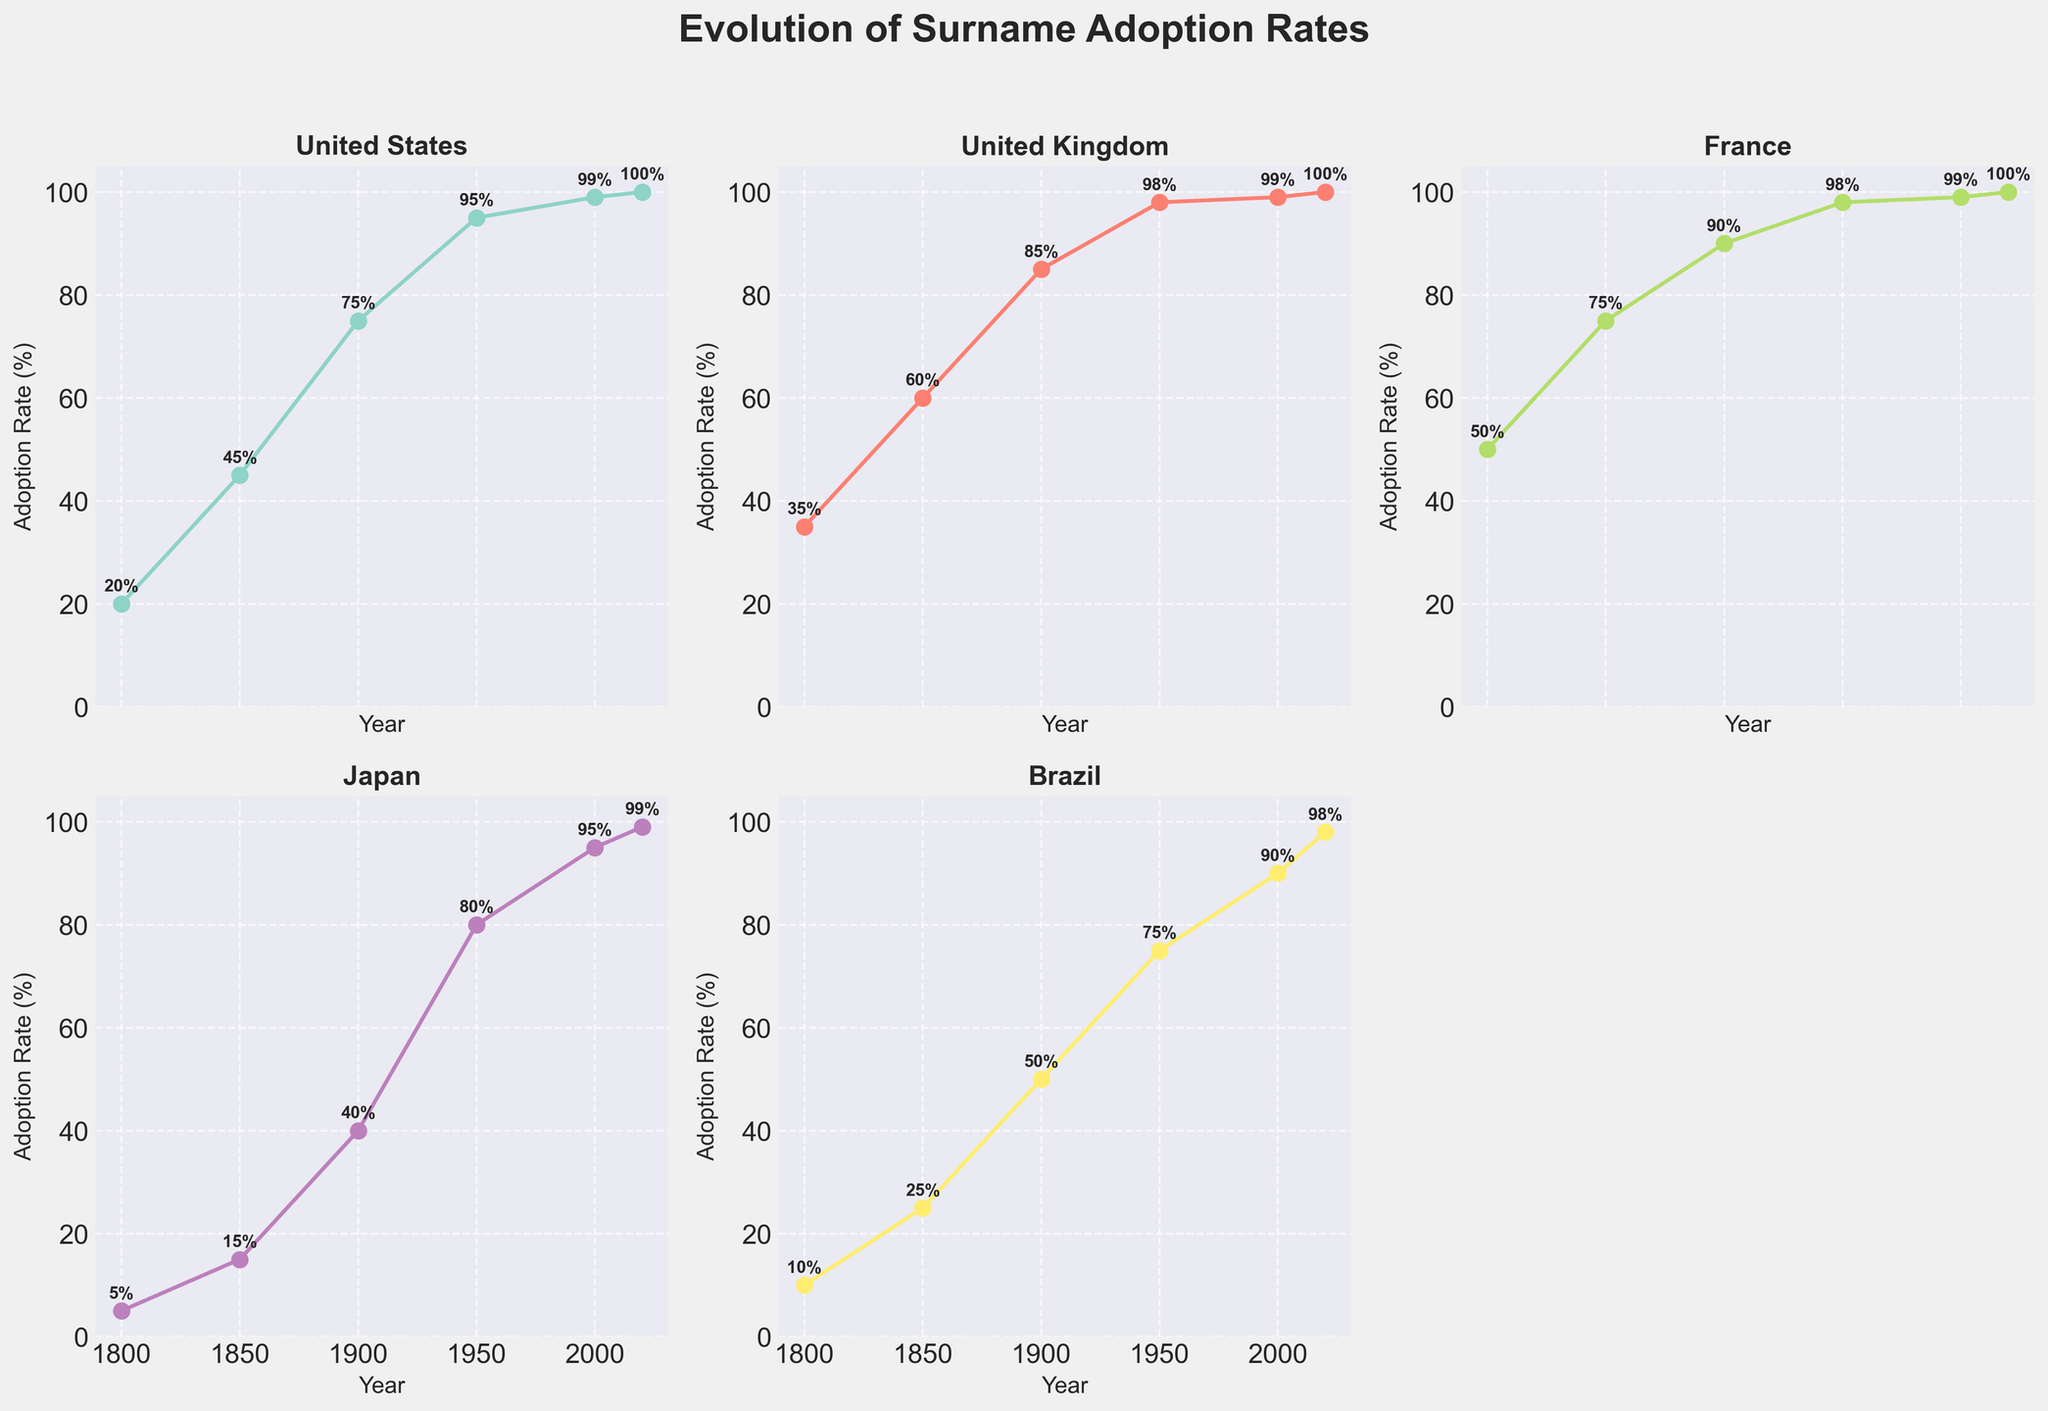What is the title of the figure? The title is displayed at the top of the figure and helps to understand the overall content of the plots. The title reads "Evolution of Surname Adoption Rates".
Answer: Evolution of Surname Adoption Rates Which country had the highest surname adoption rate in 1800? Looking at the y-values for each country's subplot in the year 1800, the country with the highest value shows the highest adoption rate for that year. France had the highest rate at 50%.
Answer: France What is the adoption rate of surnames in Japan in the year 2000? Identify the point corresponding to the year 2000 in Japan's subplot and note the y-value associated with it. For Japan, this value is 95%.
Answer: 95% How much did the adoption rate in the United States increase from 1800 to 1850? Subtract the adoption rate in 1800 from the rate in 1850 in the United States subplot. The values are 45% (1850) - 20% (1800) = 25%.
Answer: 25% Which country achieved a 100% adoption rate first, and in which year? By observing the subplots, identify the earliest year in which any country’s adoption rate reaches 100%. The United Kingdom reached 100% first in 2020.
Answer: United Kingdom, 2020 What is the average adoption rate increase per century for Brazil from 1800 to 2020? Calculate the total increase from 1800 to 2020, then divide by the number of centuries (2). The rate increased from 10% to 98%, so (98 - 10) / 2 = 44%.
Answer: 44% Compare the surname adoption rates of France and Brazil in 1950. Which country had a higher rate, and by how much? Check the y-values for both countries in 1950 on their respective subplots. France had 98%, and Brazil had 75%, so France had a higher rate by (98 - 75) = 23%.
Answer: France, 23% By what percentage did the adoption rate in Japan increase between 1850 to 1950? Subtract the value of 1850 from that of 1950 in Japan's subplot (80% - 15% = 65%). So, the increase is 65%.
Answer: 65% What's the difference in surname adoption rates between the United States and the United Kingdom in the year 2000? Compare the y-values for both countries in the year 2000. Both the United States and the United Kingdom have a 99% adoption rate, so the difference is 0%.
Answer: 0% In which country did the surname adoption rate increase the most between 1900 and 2020? Calculate the increase for each country between 1900 and 2020 and determine the highest one. For Brazil, the increase is the highest: (98% - 50% = 48%).
Answer: Brazil 